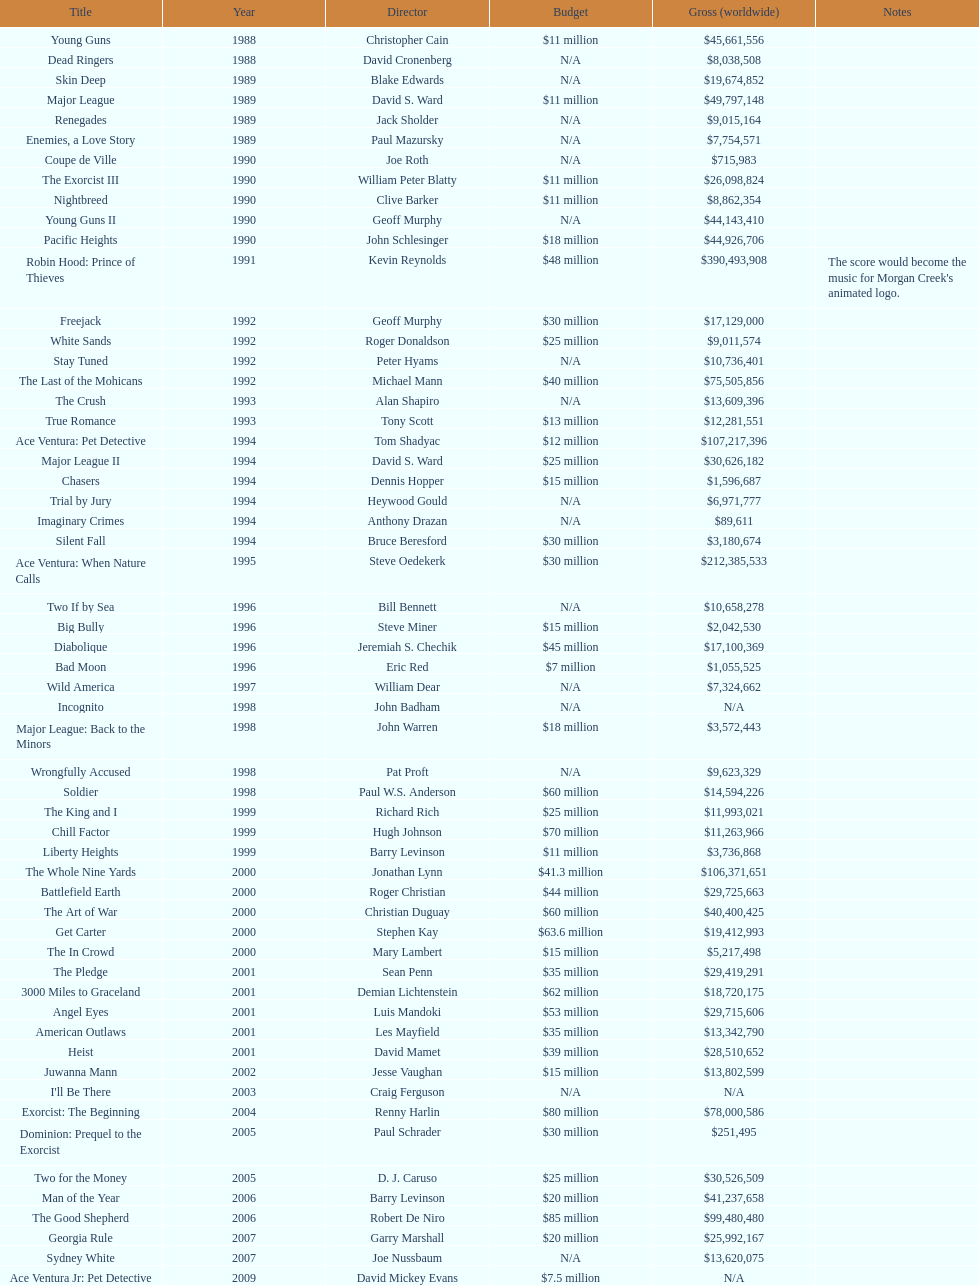Which movie was launched after bad moon? Wild America. 